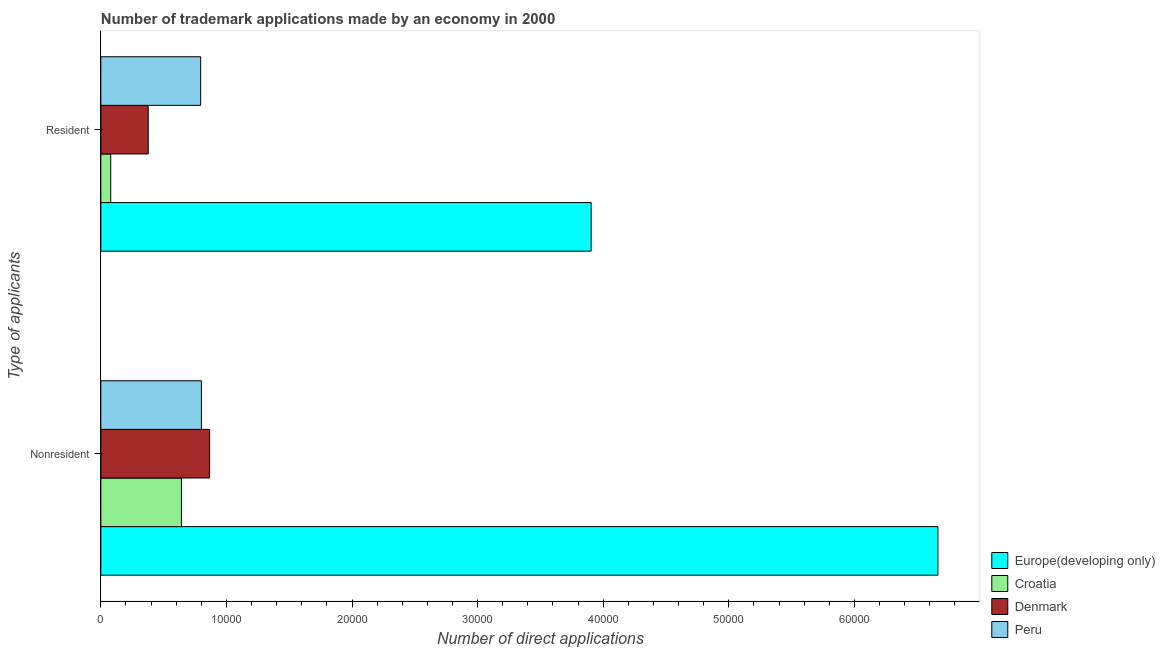How many groups of bars are there?
Make the answer very short. 2. How many bars are there on the 1st tick from the top?
Your response must be concise. 4. How many bars are there on the 1st tick from the bottom?
Offer a very short reply. 4. What is the label of the 2nd group of bars from the top?
Your answer should be very brief. Nonresident. What is the number of trademark applications made by non residents in Peru?
Your answer should be compact. 8007. Across all countries, what is the maximum number of trademark applications made by residents?
Provide a succinct answer. 3.90e+04. Across all countries, what is the minimum number of trademark applications made by non residents?
Keep it short and to the point. 6417. In which country was the number of trademark applications made by non residents maximum?
Provide a succinct answer. Europe(developing only). In which country was the number of trademark applications made by residents minimum?
Ensure brevity in your answer.  Croatia. What is the total number of trademark applications made by non residents in the graph?
Your answer should be compact. 8.97e+04. What is the difference between the number of trademark applications made by non residents in Denmark and that in Europe(developing only)?
Your answer should be compact. -5.80e+04. What is the difference between the number of trademark applications made by residents in Denmark and the number of trademark applications made by non residents in Croatia?
Keep it short and to the point. -2644. What is the average number of trademark applications made by non residents per country?
Your response must be concise. 2.24e+04. What is the difference between the number of trademark applications made by residents and number of trademark applications made by non residents in Denmark?
Offer a terse response. -4887. In how many countries, is the number of trademark applications made by residents greater than 56000 ?
Ensure brevity in your answer.  0. What is the ratio of the number of trademark applications made by non residents in Denmark to that in Europe(developing only)?
Your answer should be compact. 0.13. Is the number of trademark applications made by non residents in Peru less than that in Denmark?
Your answer should be very brief. Yes. What does the 3rd bar from the top in Nonresident represents?
Offer a terse response. Croatia. What does the 1st bar from the bottom in Nonresident represents?
Offer a very short reply. Europe(developing only). How many bars are there?
Your answer should be very brief. 8. Are the values on the major ticks of X-axis written in scientific E-notation?
Give a very brief answer. No. Does the graph contain any zero values?
Keep it short and to the point. No. What is the title of the graph?
Provide a short and direct response. Number of trademark applications made by an economy in 2000. Does "St. Martin (French part)" appear as one of the legend labels in the graph?
Ensure brevity in your answer.  No. What is the label or title of the X-axis?
Offer a very short reply. Number of direct applications. What is the label or title of the Y-axis?
Your answer should be compact. Type of applicants. What is the Number of direct applications of Europe(developing only) in Nonresident?
Make the answer very short. 6.66e+04. What is the Number of direct applications of Croatia in Nonresident?
Provide a succinct answer. 6417. What is the Number of direct applications in Denmark in Nonresident?
Make the answer very short. 8660. What is the Number of direct applications in Peru in Nonresident?
Your answer should be compact. 8007. What is the Number of direct applications of Europe(developing only) in Resident?
Provide a succinct answer. 3.90e+04. What is the Number of direct applications in Croatia in Resident?
Offer a very short reply. 788. What is the Number of direct applications in Denmark in Resident?
Give a very brief answer. 3773. What is the Number of direct applications in Peru in Resident?
Give a very brief answer. 7948. Across all Type of applicants, what is the maximum Number of direct applications in Europe(developing only)?
Your answer should be very brief. 6.66e+04. Across all Type of applicants, what is the maximum Number of direct applications of Croatia?
Offer a very short reply. 6417. Across all Type of applicants, what is the maximum Number of direct applications in Denmark?
Provide a short and direct response. 8660. Across all Type of applicants, what is the maximum Number of direct applications in Peru?
Make the answer very short. 8007. Across all Type of applicants, what is the minimum Number of direct applications of Europe(developing only)?
Provide a succinct answer. 3.90e+04. Across all Type of applicants, what is the minimum Number of direct applications of Croatia?
Your response must be concise. 788. Across all Type of applicants, what is the minimum Number of direct applications of Denmark?
Make the answer very short. 3773. Across all Type of applicants, what is the minimum Number of direct applications of Peru?
Your answer should be very brief. 7948. What is the total Number of direct applications of Europe(developing only) in the graph?
Your answer should be compact. 1.06e+05. What is the total Number of direct applications in Croatia in the graph?
Give a very brief answer. 7205. What is the total Number of direct applications in Denmark in the graph?
Offer a very short reply. 1.24e+04. What is the total Number of direct applications in Peru in the graph?
Offer a very short reply. 1.60e+04. What is the difference between the Number of direct applications in Europe(developing only) in Nonresident and that in Resident?
Keep it short and to the point. 2.76e+04. What is the difference between the Number of direct applications in Croatia in Nonresident and that in Resident?
Give a very brief answer. 5629. What is the difference between the Number of direct applications of Denmark in Nonresident and that in Resident?
Provide a succinct answer. 4887. What is the difference between the Number of direct applications in Peru in Nonresident and that in Resident?
Provide a short and direct response. 59. What is the difference between the Number of direct applications in Europe(developing only) in Nonresident and the Number of direct applications in Croatia in Resident?
Provide a succinct answer. 6.59e+04. What is the difference between the Number of direct applications in Europe(developing only) in Nonresident and the Number of direct applications in Denmark in Resident?
Provide a succinct answer. 6.29e+04. What is the difference between the Number of direct applications of Europe(developing only) in Nonresident and the Number of direct applications of Peru in Resident?
Your response must be concise. 5.87e+04. What is the difference between the Number of direct applications of Croatia in Nonresident and the Number of direct applications of Denmark in Resident?
Your answer should be compact. 2644. What is the difference between the Number of direct applications of Croatia in Nonresident and the Number of direct applications of Peru in Resident?
Provide a succinct answer. -1531. What is the difference between the Number of direct applications in Denmark in Nonresident and the Number of direct applications in Peru in Resident?
Provide a succinct answer. 712. What is the average Number of direct applications of Europe(developing only) per Type of applicants?
Provide a succinct answer. 5.28e+04. What is the average Number of direct applications of Croatia per Type of applicants?
Your answer should be compact. 3602.5. What is the average Number of direct applications in Denmark per Type of applicants?
Ensure brevity in your answer.  6216.5. What is the average Number of direct applications in Peru per Type of applicants?
Provide a short and direct response. 7977.5. What is the difference between the Number of direct applications of Europe(developing only) and Number of direct applications of Croatia in Nonresident?
Your response must be concise. 6.02e+04. What is the difference between the Number of direct applications of Europe(developing only) and Number of direct applications of Denmark in Nonresident?
Give a very brief answer. 5.80e+04. What is the difference between the Number of direct applications of Europe(developing only) and Number of direct applications of Peru in Nonresident?
Give a very brief answer. 5.86e+04. What is the difference between the Number of direct applications of Croatia and Number of direct applications of Denmark in Nonresident?
Make the answer very short. -2243. What is the difference between the Number of direct applications of Croatia and Number of direct applications of Peru in Nonresident?
Offer a terse response. -1590. What is the difference between the Number of direct applications of Denmark and Number of direct applications of Peru in Nonresident?
Your response must be concise. 653. What is the difference between the Number of direct applications in Europe(developing only) and Number of direct applications in Croatia in Resident?
Offer a very short reply. 3.83e+04. What is the difference between the Number of direct applications of Europe(developing only) and Number of direct applications of Denmark in Resident?
Keep it short and to the point. 3.53e+04. What is the difference between the Number of direct applications in Europe(developing only) and Number of direct applications in Peru in Resident?
Offer a terse response. 3.11e+04. What is the difference between the Number of direct applications of Croatia and Number of direct applications of Denmark in Resident?
Ensure brevity in your answer.  -2985. What is the difference between the Number of direct applications of Croatia and Number of direct applications of Peru in Resident?
Offer a very short reply. -7160. What is the difference between the Number of direct applications of Denmark and Number of direct applications of Peru in Resident?
Give a very brief answer. -4175. What is the ratio of the Number of direct applications in Europe(developing only) in Nonresident to that in Resident?
Keep it short and to the point. 1.71. What is the ratio of the Number of direct applications in Croatia in Nonresident to that in Resident?
Provide a succinct answer. 8.14. What is the ratio of the Number of direct applications in Denmark in Nonresident to that in Resident?
Offer a very short reply. 2.3. What is the ratio of the Number of direct applications in Peru in Nonresident to that in Resident?
Keep it short and to the point. 1.01. What is the difference between the highest and the second highest Number of direct applications of Europe(developing only)?
Ensure brevity in your answer.  2.76e+04. What is the difference between the highest and the second highest Number of direct applications of Croatia?
Keep it short and to the point. 5629. What is the difference between the highest and the second highest Number of direct applications in Denmark?
Offer a terse response. 4887. What is the difference between the highest and the lowest Number of direct applications of Europe(developing only)?
Ensure brevity in your answer.  2.76e+04. What is the difference between the highest and the lowest Number of direct applications in Croatia?
Provide a short and direct response. 5629. What is the difference between the highest and the lowest Number of direct applications of Denmark?
Your answer should be very brief. 4887. 